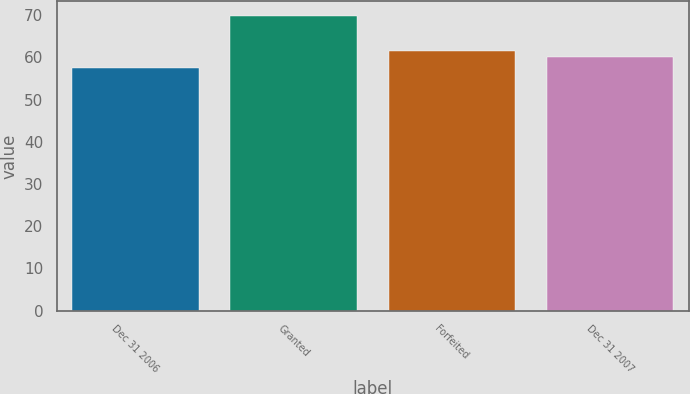Convert chart. <chart><loc_0><loc_0><loc_500><loc_500><bar_chart><fcel>Dec 31 2006<fcel>Granted<fcel>Forfeited<fcel>Dec 31 2007<nl><fcel>57.45<fcel>69.86<fcel>61.44<fcel>60.2<nl></chart> 